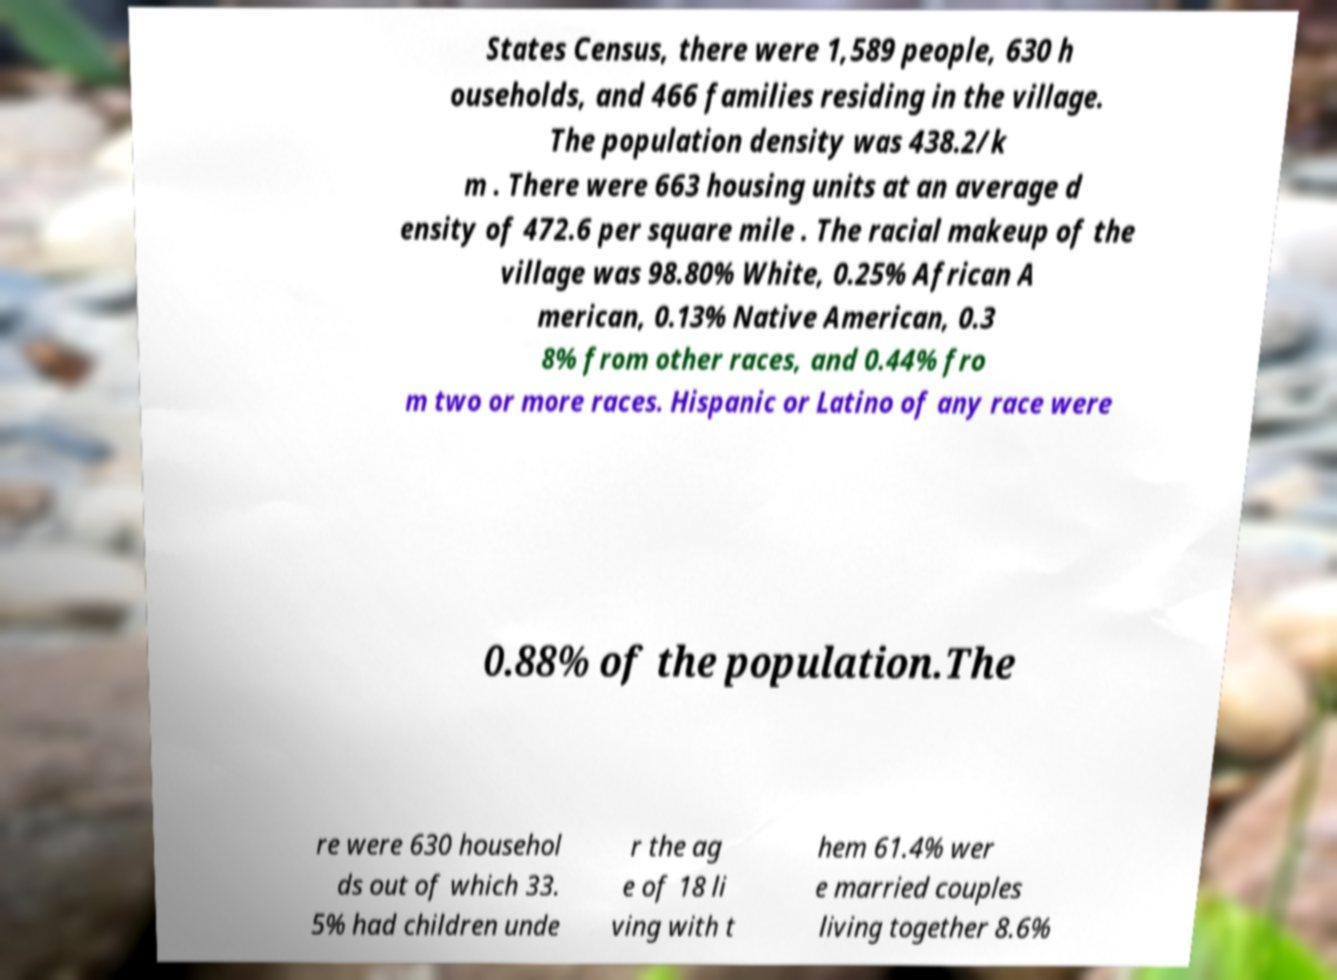There's text embedded in this image that I need extracted. Can you transcribe it verbatim? States Census, there were 1,589 people, 630 h ouseholds, and 466 families residing in the village. The population density was 438.2/k m . There were 663 housing units at an average d ensity of 472.6 per square mile . The racial makeup of the village was 98.80% White, 0.25% African A merican, 0.13% Native American, 0.3 8% from other races, and 0.44% fro m two or more races. Hispanic or Latino of any race were 0.88% of the population.The re were 630 househol ds out of which 33. 5% had children unde r the ag e of 18 li ving with t hem 61.4% wer e married couples living together 8.6% 